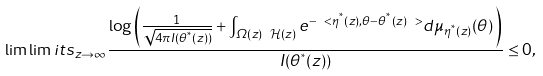<formula> <loc_0><loc_0><loc_500><loc_500>\lim \lim i t s _ { z \to \infty } \frac { \log \left ( \frac { 1 } { \sqrt { 4 \pi I ( \theta ^ { ^ { * } } ( z ) ) } } + \int _ { \varOmega ( z ) \ \mathcal { H } ( z ) } e ^ { - \ < \eta ^ { ^ { * } } ( z ) , \theta - \theta ^ { ^ { * } } ( z ) \ > } d \mu _ { \eta ^ { ^ { * } } ( z ) } ( \theta ) \, \right ) } { I ( \theta ^ { ^ { * } } ( z ) ) } \leq 0 ,</formula> 